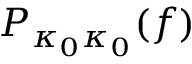<formula> <loc_0><loc_0><loc_500><loc_500>P _ { \kappa _ { 0 } \kappa _ { 0 } } ( f )</formula> 